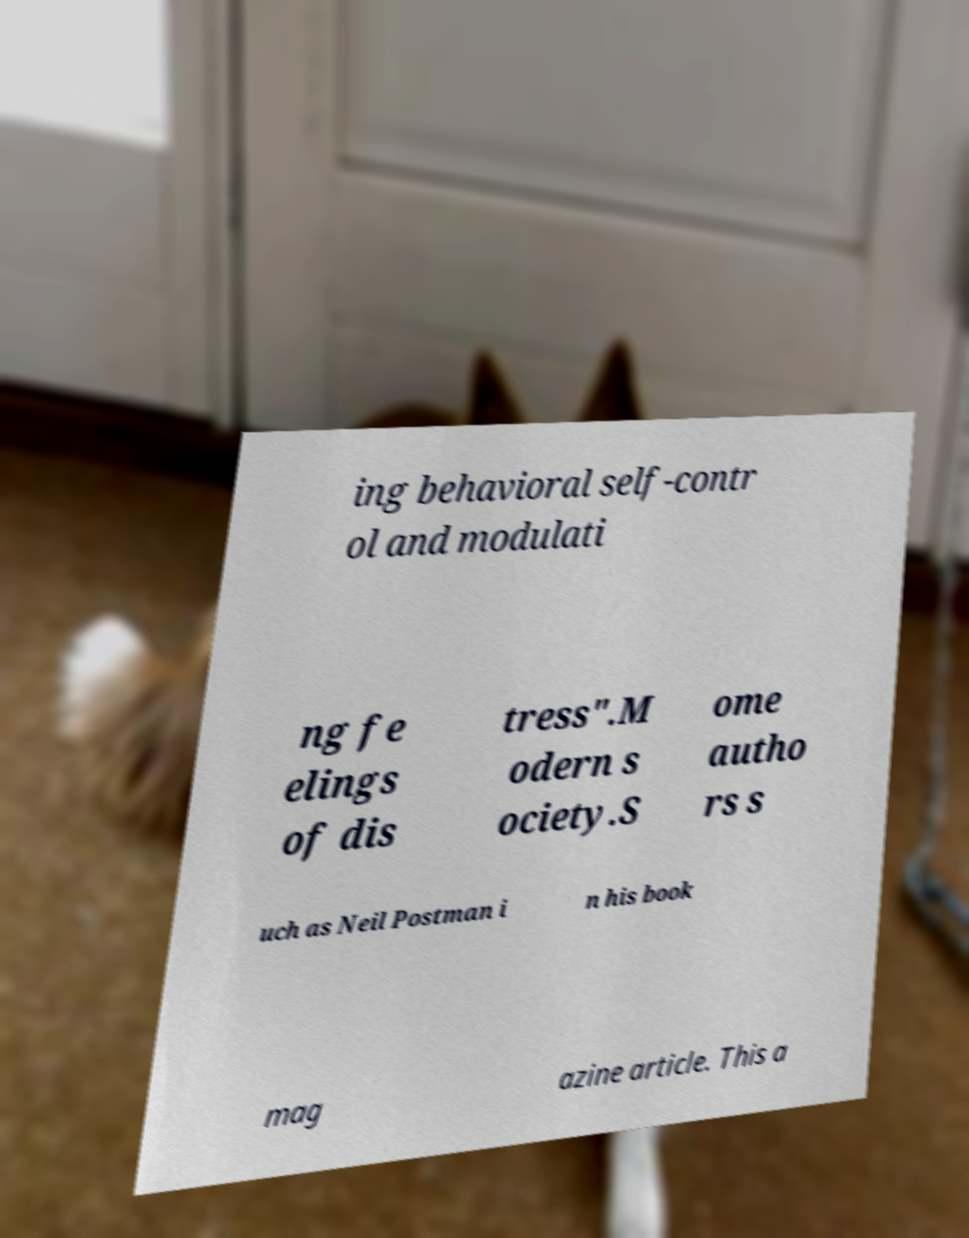Please read and relay the text visible in this image. What does it say? ing behavioral self-contr ol and modulati ng fe elings of dis tress".M odern s ociety.S ome autho rs s uch as Neil Postman i n his book mag azine article. This a 